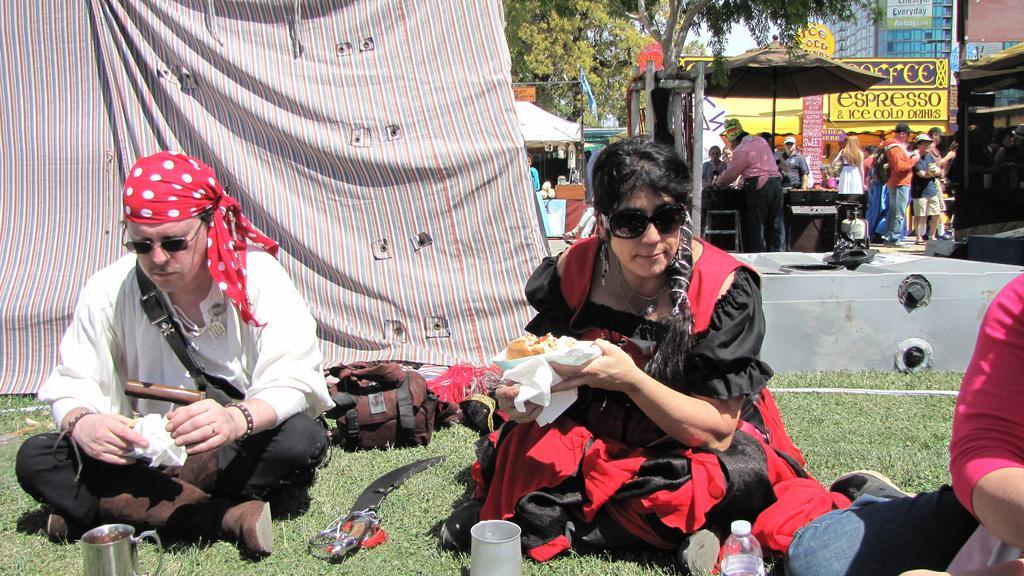Can you describe this image briefly? In this image I can see some people are sitting on the grass. I can see some food item in their hands. In the background, I can see the trees and a building with some text written on it. 